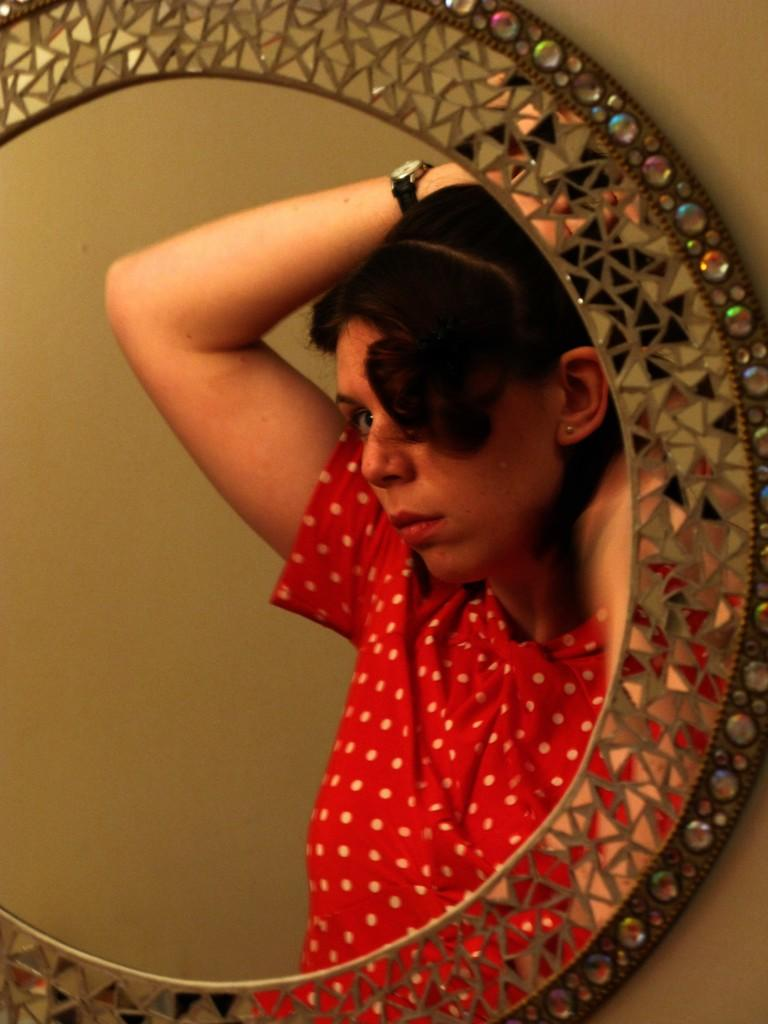What object is attached to the wall in the image? There is a mirror on the wall in the image. What can be seen in the mirror? There is a reflection of a woman in the mirror. What is the woman wearing on her upper body? The woman is wearing a red color top. What accessory is the woman wearing on her wrist? The woman is wearing a watch. What type of bells can be heard ringing in the image? There are no bells present in the image, and therefore no sound can be heard. 